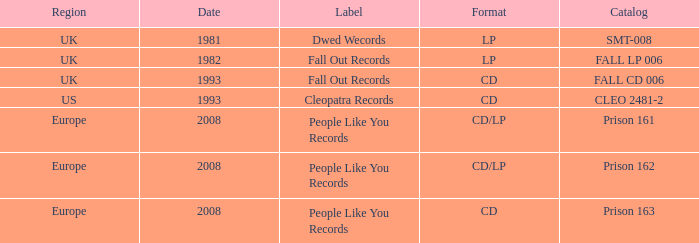Which format includes a date of 1993, and a catalog of cleo 2481-2? CD. 